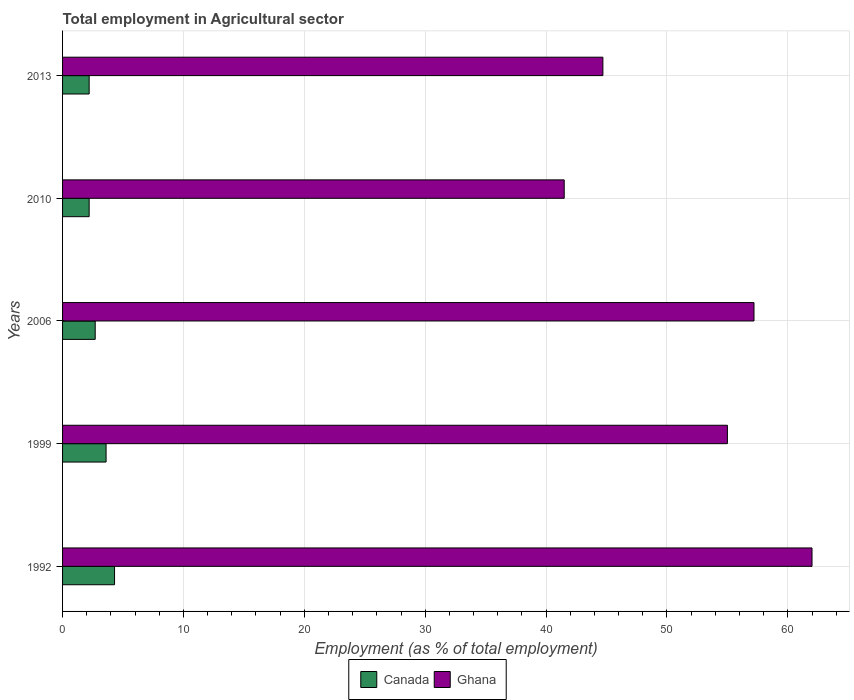Are the number of bars on each tick of the Y-axis equal?
Your answer should be compact. Yes. How many bars are there on the 4th tick from the top?
Ensure brevity in your answer.  2. How many bars are there on the 5th tick from the bottom?
Make the answer very short. 2. What is the label of the 5th group of bars from the top?
Offer a very short reply. 1992. In how many cases, is the number of bars for a given year not equal to the number of legend labels?
Your response must be concise. 0. What is the employment in agricultural sector in Canada in 1999?
Provide a succinct answer. 3.6. Across all years, what is the minimum employment in agricultural sector in Canada?
Your response must be concise. 2.2. What is the total employment in agricultural sector in Ghana in the graph?
Provide a short and direct response. 260.4. What is the difference between the employment in agricultural sector in Ghana in 1999 and that in 2013?
Give a very brief answer. 10.3. What is the difference between the employment in agricultural sector in Ghana in 1992 and the employment in agricultural sector in Canada in 1999?
Your answer should be compact. 58.4. What is the average employment in agricultural sector in Canada per year?
Ensure brevity in your answer.  3. In the year 2010, what is the difference between the employment in agricultural sector in Ghana and employment in agricultural sector in Canada?
Keep it short and to the point. 39.3. In how many years, is the employment in agricultural sector in Canada greater than 8 %?
Offer a terse response. 0. What is the ratio of the employment in agricultural sector in Ghana in 1999 to that in 2013?
Make the answer very short. 1.23. What is the difference between the highest and the second highest employment in agricultural sector in Ghana?
Give a very brief answer. 4.8. What is the difference between the highest and the lowest employment in agricultural sector in Ghana?
Your response must be concise. 20.5. In how many years, is the employment in agricultural sector in Canada greater than the average employment in agricultural sector in Canada taken over all years?
Give a very brief answer. 2. Is the sum of the employment in agricultural sector in Canada in 1992 and 2006 greater than the maximum employment in agricultural sector in Ghana across all years?
Offer a terse response. No. What does the 2nd bar from the bottom in 2010 represents?
Offer a very short reply. Ghana. What is the difference between two consecutive major ticks on the X-axis?
Offer a terse response. 10. Are the values on the major ticks of X-axis written in scientific E-notation?
Provide a short and direct response. No. Where does the legend appear in the graph?
Your response must be concise. Bottom center. What is the title of the graph?
Make the answer very short. Total employment in Agricultural sector. Does "Colombia" appear as one of the legend labels in the graph?
Offer a terse response. No. What is the label or title of the X-axis?
Keep it short and to the point. Employment (as % of total employment). What is the label or title of the Y-axis?
Make the answer very short. Years. What is the Employment (as % of total employment) in Canada in 1992?
Offer a very short reply. 4.3. What is the Employment (as % of total employment) of Ghana in 1992?
Provide a succinct answer. 62. What is the Employment (as % of total employment) in Canada in 1999?
Ensure brevity in your answer.  3.6. What is the Employment (as % of total employment) of Ghana in 1999?
Keep it short and to the point. 55. What is the Employment (as % of total employment) of Canada in 2006?
Your answer should be very brief. 2.7. What is the Employment (as % of total employment) in Ghana in 2006?
Keep it short and to the point. 57.2. What is the Employment (as % of total employment) in Canada in 2010?
Your answer should be compact. 2.2. What is the Employment (as % of total employment) of Ghana in 2010?
Make the answer very short. 41.5. What is the Employment (as % of total employment) in Canada in 2013?
Give a very brief answer. 2.2. What is the Employment (as % of total employment) of Ghana in 2013?
Keep it short and to the point. 44.7. Across all years, what is the maximum Employment (as % of total employment) in Canada?
Your answer should be very brief. 4.3. Across all years, what is the maximum Employment (as % of total employment) in Ghana?
Your response must be concise. 62. Across all years, what is the minimum Employment (as % of total employment) of Canada?
Your answer should be compact. 2.2. Across all years, what is the minimum Employment (as % of total employment) in Ghana?
Ensure brevity in your answer.  41.5. What is the total Employment (as % of total employment) in Canada in the graph?
Provide a succinct answer. 15. What is the total Employment (as % of total employment) of Ghana in the graph?
Give a very brief answer. 260.4. What is the difference between the Employment (as % of total employment) in Canada in 1992 and that in 1999?
Offer a terse response. 0.7. What is the difference between the Employment (as % of total employment) in Ghana in 1992 and that in 1999?
Provide a succinct answer. 7. What is the difference between the Employment (as % of total employment) of Canada in 1992 and that in 2006?
Your answer should be compact. 1.6. What is the difference between the Employment (as % of total employment) in Canada in 1992 and that in 2013?
Provide a succinct answer. 2.1. What is the difference between the Employment (as % of total employment) in Ghana in 1992 and that in 2013?
Provide a succinct answer. 17.3. What is the difference between the Employment (as % of total employment) in Canada in 1999 and that in 2010?
Keep it short and to the point. 1.4. What is the difference between the Employment (as % of total employment) in Canada in 1999 and that in 2013?
Provide a short and direct response. 1.4. What is the difference between the Employment (as % of total employment) of Ghana in 1999 and that in 2013?
Give a very brief answer. 10.3. What is the difference between the Employment (as % of total employment) of Ghana in 2006 and that in 2010?
Offer a terse response. 15.7. What is the difference between the Employment (as % of total employment) of Canada in 2006 and that in 2013?
Provide a short and direct response. 0.5. What is the difference between the Employment (as % of total employment) in Ghana in 2006 and that in 2013?
Your answer should be compact. 12.5. What is the difference between the Employment (as % of total employment) in Canada in 2010 and that in 2013?
Keep it short and to the point. 0. What is the difference between the Employment (as % of total employment) in Canada in 1992 and the Employment (as % of total employment) in Ghana in 1999?
Your answer should be very brief. -50.7. What is the difference between the Employment (as % of total employment) in Canada in 1992 and the Employment (as % of total employment) in Ghana in 2006?
Offer a terse response. -52.9. What is the difference between the Employment (as % of total employment) of Canada in 1992 and the Employment (as % of total employment) of Ghana in 2010?
Your answer should be very brief. -37.2. What is the difference between the Employment (as % of total employment) in Canada in 1992 and the Employment (as % of total employment) in Ghana in 2013?
Ensure brevity in your answer.  -40.4. What is the difference between the Employment (as % of total employment) of Canada in 1999 and the Employment (as % of total employment) of Ghana in 2006?
Offer a very short reply. -53.6. What is the difference between the Employment (as % of total employment) of Canada in 1999 and the Employment (as % of total employment) of Ghana in 2010?
Give a very brief answer. -37.9. What is the difference between the Employment (as % of total employment) of Canada in 1999 and the Employment (as % of total employment) of Ghana in 2013?
Your answer should be compact. -41.1. What is the difference between the Employment (as % of total employment) in Canada in 2006 and the Employment (as % of total employment) in Ghana in 2010?
Keep it short and to the point. -38.8. What is the difference between the Employment (as % of total employment) of Canada in 2006 and the Employment (as % of total employment) of Ghana in 2013?
Offer a terse response. -42. What is the difference between the Employment (as % of total employment) of Canada in 2010 and the Employment (as % of total employment) of Ghana in 2013?
Offer a very short reply. -42.5. What is the average Employment (as % of total employment) in Ghana per year?
Your answer should be very brief. 52.08. In the year 1992, what is the difference between the Employment (as % of total employment) of Canada and Employment (as % of total employment) of Ghana?
Your answer should be compact. -57.7. In the year 1999, what is the difference between the Employment (as % of total employment) of Canada and Employment (as % of total employment) of Ghana?
Offer a terse response. -51.4. In the year 2006, what is the difference between the Employment (as % of total employment) in Canada and Employment (as % of total employment) in Ghana?
Keep it short and to the point. -54.5. In the year 2010, what is the difference between the Employment (as % of total employment) of Canada and Employment (as % of total employment) of Ghana?
Ensure brevity in your answer.  -39.3. In the year 2013, what is the difference between the Employment (as % of total employment) in Canada and Employment (as % of total employment) in Ghana?
Offer a terse response. -42.5. What is the ratio of the Employment (as % of total employment) in Canada in 1992 to that in 1999?
Your answer should be very brief. 1.19. What is the ratio of the Employment (as % of total employment) in Ghana in 1992 to that in 1999?
Give a very brief answer. 1.13. What is the ratio of the Employment (as % of total employment) of Canada in 1992 to that in 2006?
Provide a short and direct response. 1.59. What is the ratio of the Employment (as % of total employment) of Ghana in 1992 to that in 2006?
Ensure brevity in your answer.  1.08. What is the ratio of the Employment (as % of total employment) in Canada in 1992 to that in 2010?
Your answer should be very brief. 1.95. What is the ratio of the Employment (as % of total employment) of Ghana in 1992 to that in 2010?
Your answer should be compact. 1.49. What is the ratio of the Employment (as % of total employment) of Canada in 1992 to that in 2013?
Keep it short and to the point. 1.95. What is the ratio of the Employment (as % of total employment) in Ghana in 1992 to that in 2013?
Provide a short and direct response. 1.39. What is the ratio of the Employment (as % of total employment) of Ghana in 1999 to that in 2006?
Keep it short and to the point. 0.96. What is the ratio of the Employment (as % of total employment) of Canada in 1999 to that in 2010?
Offer a very short reply. 1.64. What is the ratio of the Employment (as % of total employment) in Ghana in 1999 to that in 2010?
Give a very brief answer. 1.33. What is the ratio of the Employment (as % of total employment) in Canada in 1999 to that in 2013?
Your answer should be compact. 1.64. What is the ratio of the Employment (as % of total employment) in Ghana in 1999 to that in 2013?
Provide a succinct answer. 1.23. What is the ratio of the Employment (as % of total employment) in Canada in 2006 to that in 2010?
Give a very brief answer. 1.23. What is the ratio of the Employment (as % of total employment) in Ghana in 2006 to that in 2010?
Your answer should be very brief. 1.38. What is the ratio of the Employment (as % of total employment) of Canada in 2006 to that in 2013?
Your answer should be compact. 1.23. What is the ratio of the Employment (as % of total employment) in Ghana in 2006 to that in 2013?
Offer a very short reply. 1.28. What is the ratio of the Employment (as % of total employment) of Ghana in 2010 to that in 2013?
Give a very brief answer. 0.93. What is the difference between the highest and the second highest Employment (as % of total employment) in Canada?
Provide a succinct answer. 0.7. What is the difference between the highest and the lowest Employment (as % of total employment) of Canada?
Provide a succinct answer. 2.1. 